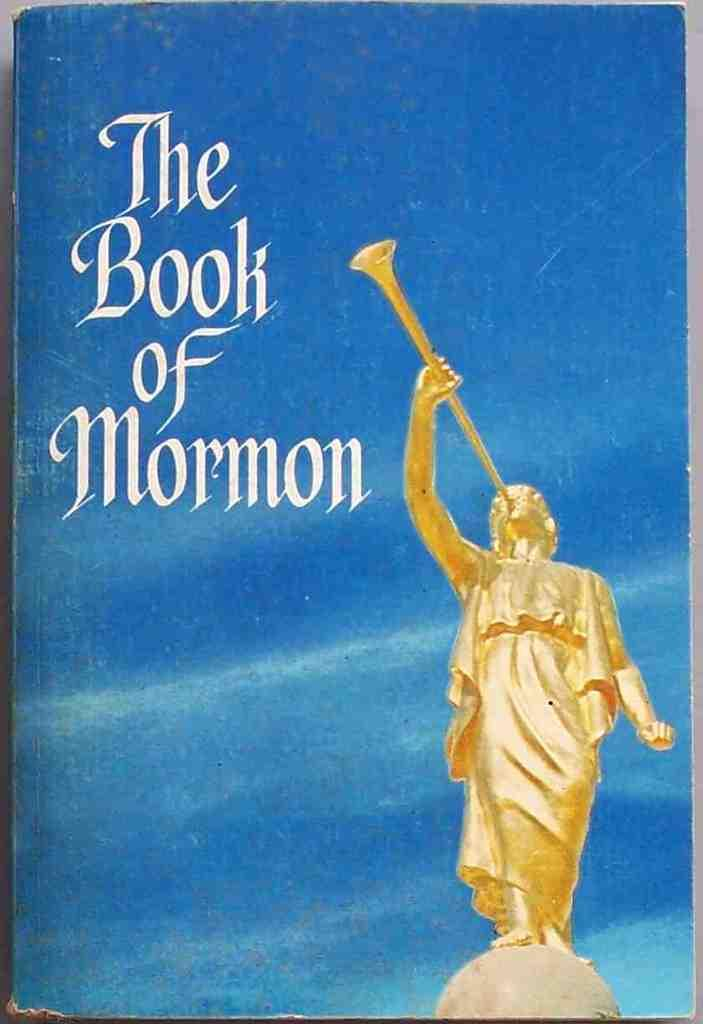What is the main subject of the image? The main subject of the image is the cover page of a book. What is depicted on the cover page of the book? The book contains a statue. What else can be found inside the book? There is some text present in the book. What type of bone can be seen in the image? There is no bone present in the image; it features the cover page of a book with a statue and text. What season is depicted in the image? The image does not depict a specific season, as it only shows the cover page of a book with a statue and text. 